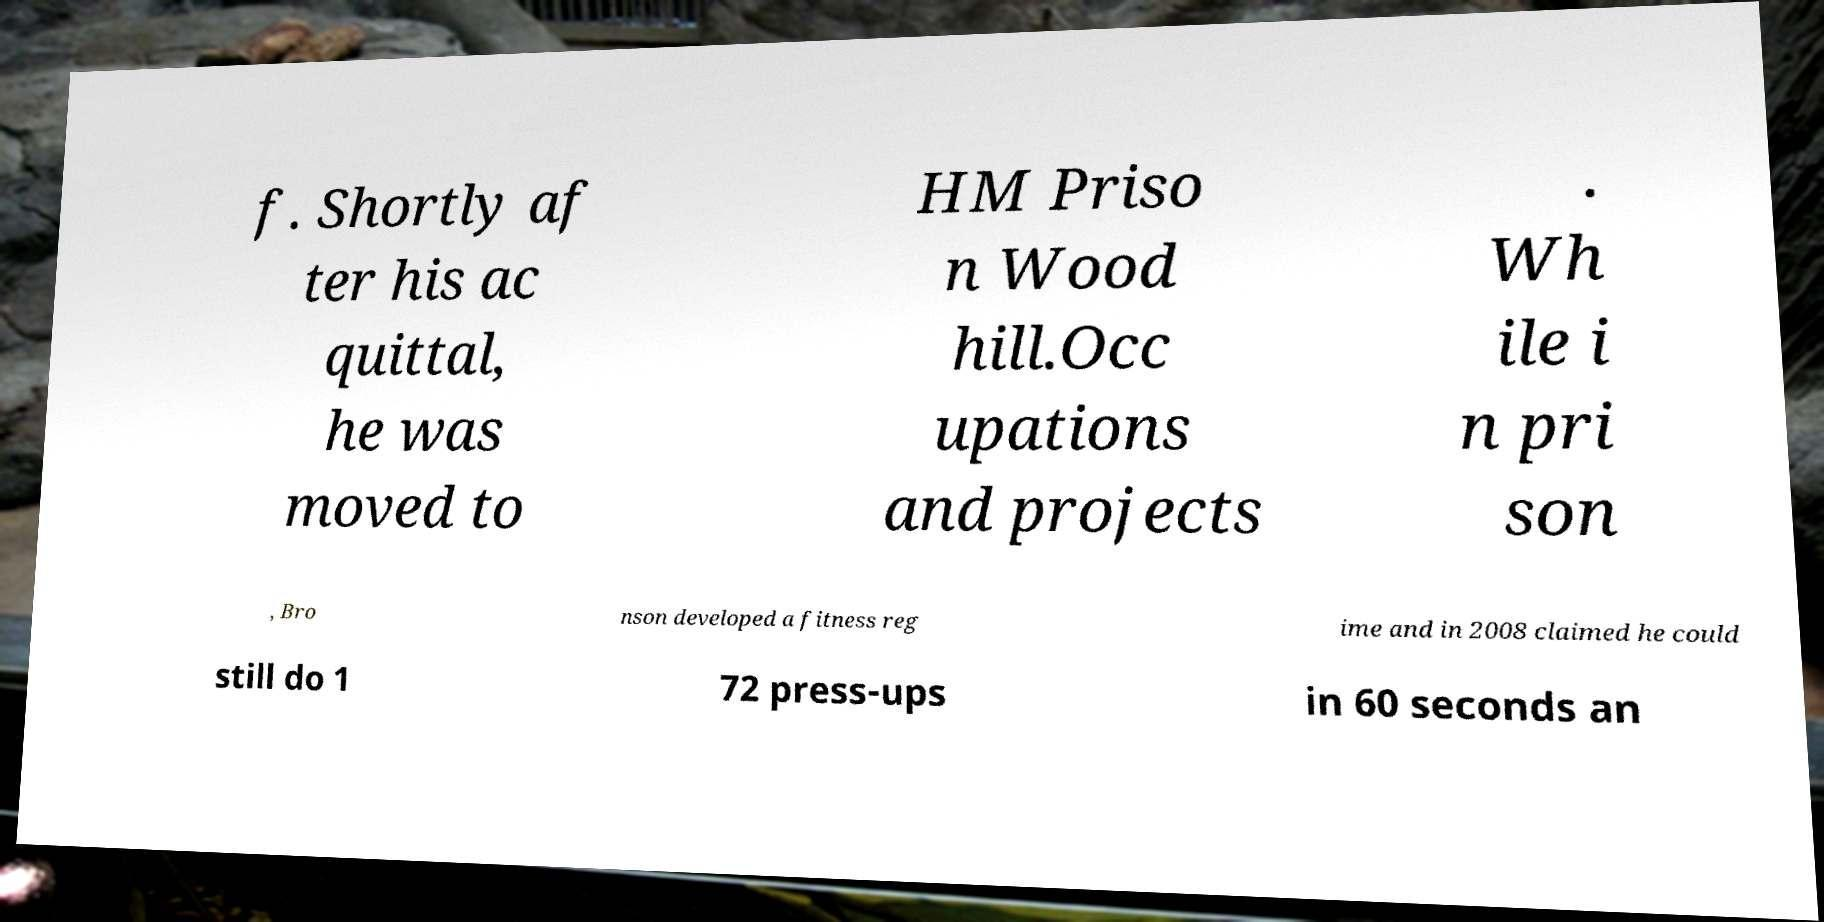There's text embedded in this image that I need extracted. Can you transcribe it verbatim? f. Shortly af ter his ac quittal, he was moved to HM Priso n Wood hill.Occ upations and projects . Wh ile i n pri son , Bro nson developed a fitness reg ime and in 2008 claimed he could still do 1 72 press-ups in 60 seconds an 